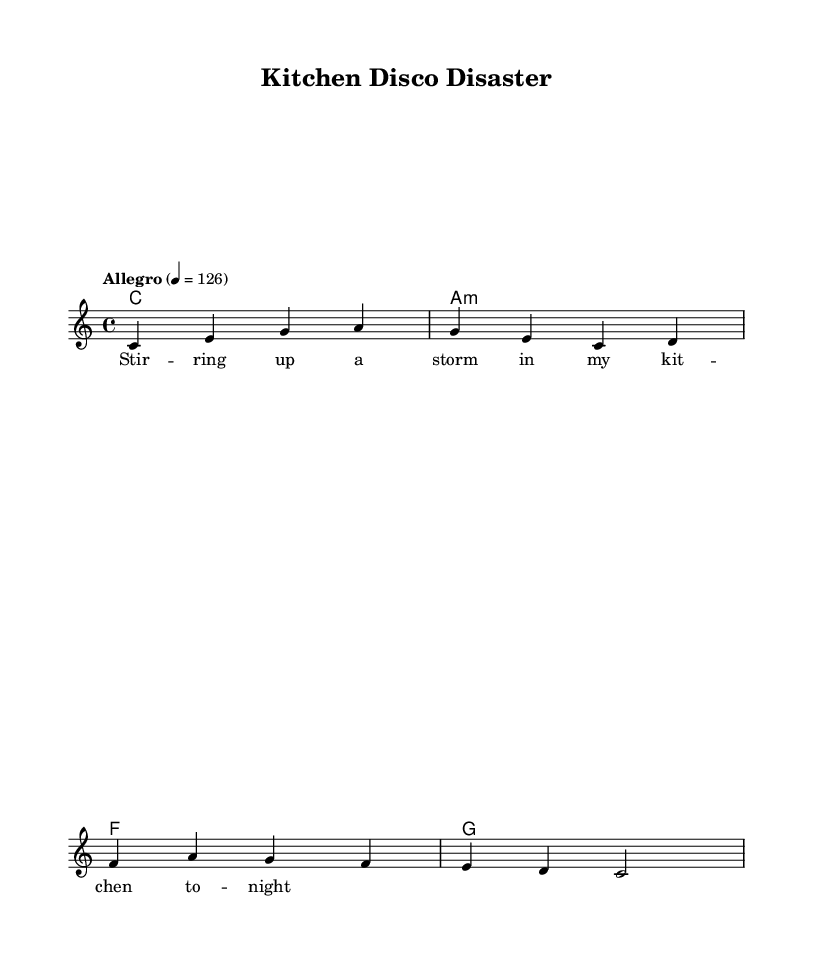What is the key signature of this music? The key signature is identified at the beginning of the score, showing that it is in the key of C major, which has no sharps or flats.
Answer: C major What is the time signature of this piece? The time signature is displayed at the beginning of the score in a mathematical format indicating the number of beats in a measure; here, it shows 4/4, meaning there are four beats per measure.
Answer: 4/4 What is the tempo marking for this piece? The tempo marking is specified in the score as "Allegro" with a metronome marking of 126, indicating a fast pace for the music.
Answer: Allegro 4 = 126 How many measures are in the melody provided? By counting the individual line segments in the melody section, we identify that there are four measures total, as indicated by the distinct divisions in the notation.
Answer: 4 What chords are used in the harmony section? The harmony section specifies three chords: C major, A minor, and F major, which can be recognized from the chord names listed under the chordmode directive.
Answer: C, A minor, F What is the main theme of the song reflected in the lyrics? The lyrics convey a playful and chaotic theme about cooking, as suggested in the line "Stirring up a storm in my kitchen tonight," reflecting a sense of whimsy associated with culinary adventures and mishaps.
Answer: Kitchen adventures 